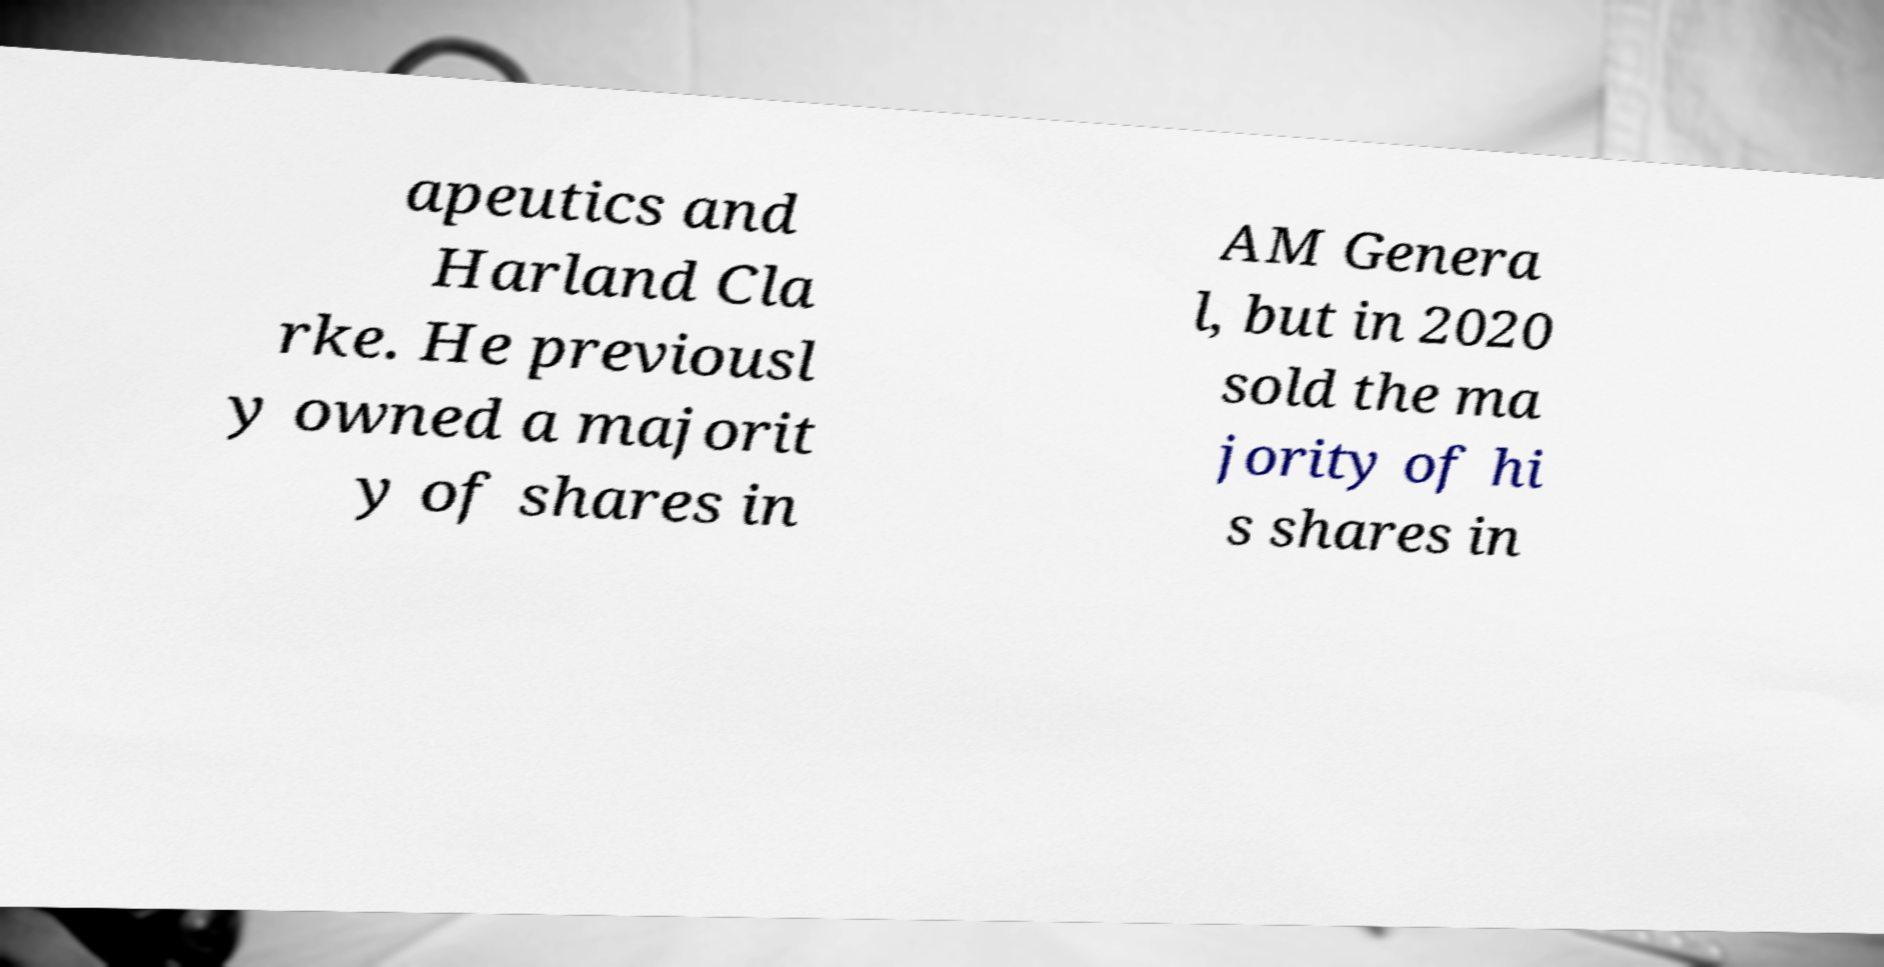What messages or text are displayed in this image? I need them in a readable, typed format. apeutics and Harland Cla rke. He previousl y owned a majorit y of shares in AM Genera l, but in 2020 sold the ma jority of hi s shares in 